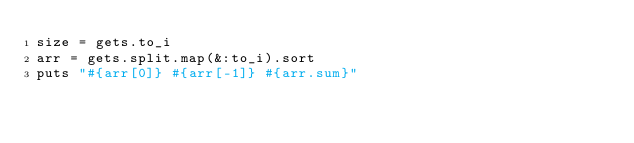<code> <loc_0><loc_0><loc_500><loc_500><_Ruby_>size = gets.to_i
arr = gets.split.map(&:to_i).sort
puts "#{arr[0]} #{arr[-1]} #{arr.sum}"
</code> 